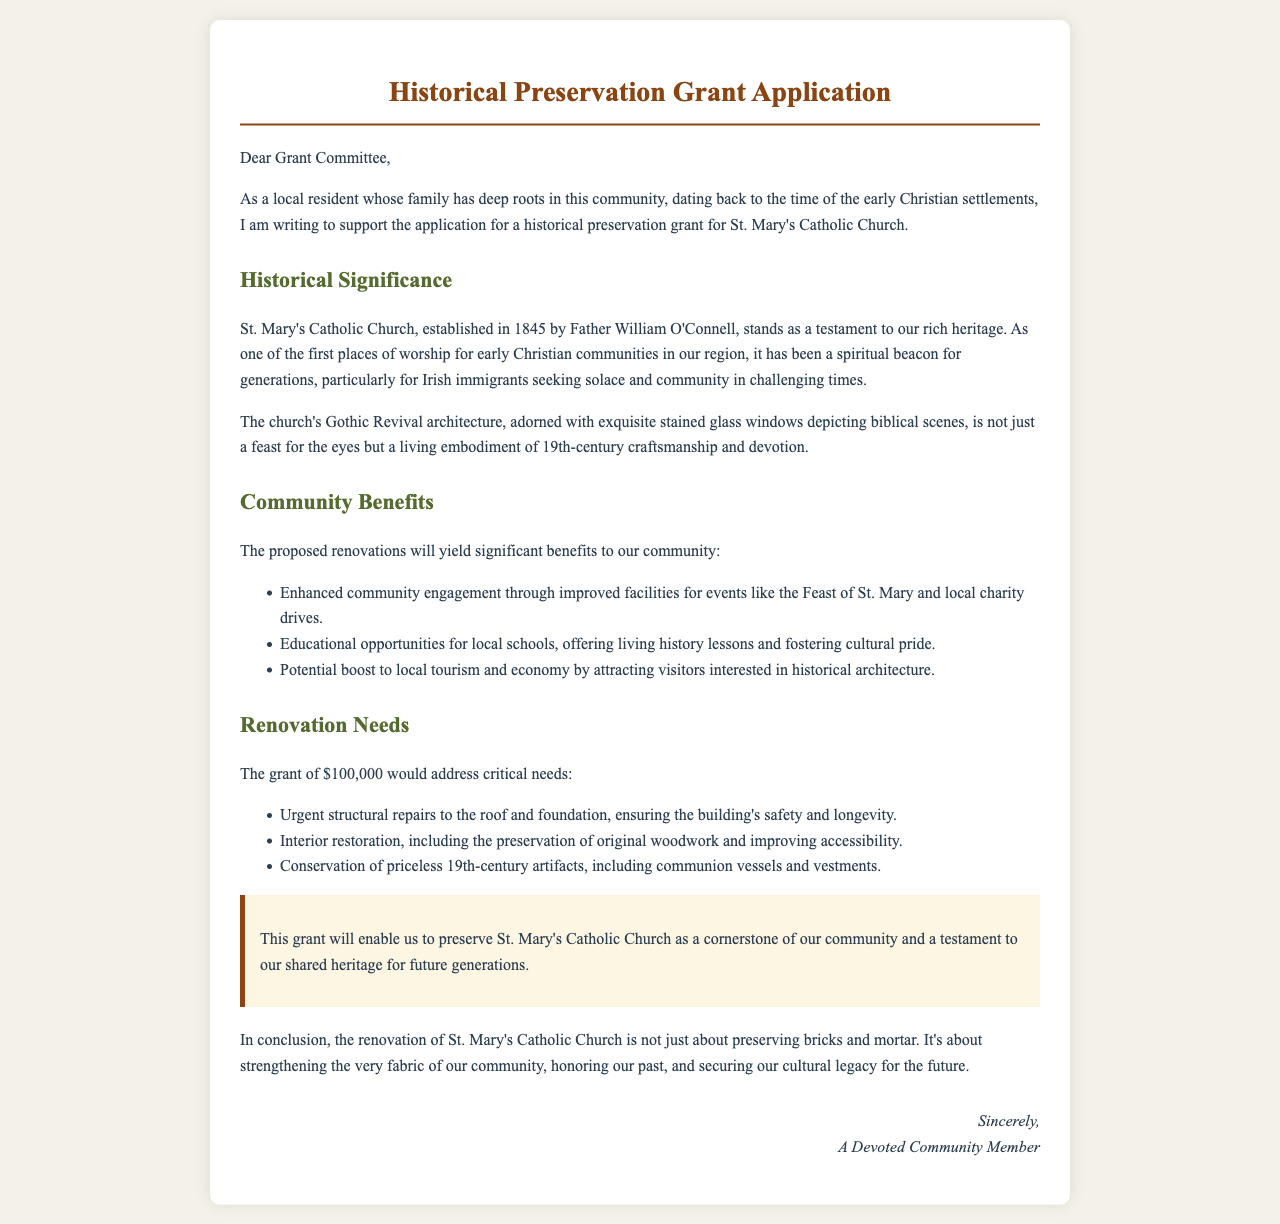What year was St. Mary's Catholic Church established? The document states it was established in 1845.
Answer: 1845 Who was the founder of St. Mary's Catholic Church? The document mentions Father William O'Connell as the founder.
Answer: Father William O'Connell How much funding is being requested for the renovations? The amount requested for the grant is specified as $100,000.
Answer: $100,000 What is one significant architectural feature of the church? The document highlights its Gothic Revival architecture.
Answer: Gothic Revival architecture What community event is mentioned that could benefit from the renovations? The proposed renovations will enhance facilities for events like the Feast of St. Mary.
Answer: Feast of St. Mary Why is St. Mary's Catholic Church considered a historical asset? It is seen as a testament to the rich heritage of early Christian communities in the region.
Answer: Rich heritage What is one benefit of the renovations related to tourism? The renovations could attract visitors interested in historical architecture, boosting local tourism.
Answer: Boosting local tourism What type of artifacts will be conserved with the grant? The document mentions priceless 19th-century artifacts, including communion vessels.
Answer: Communion vessels 